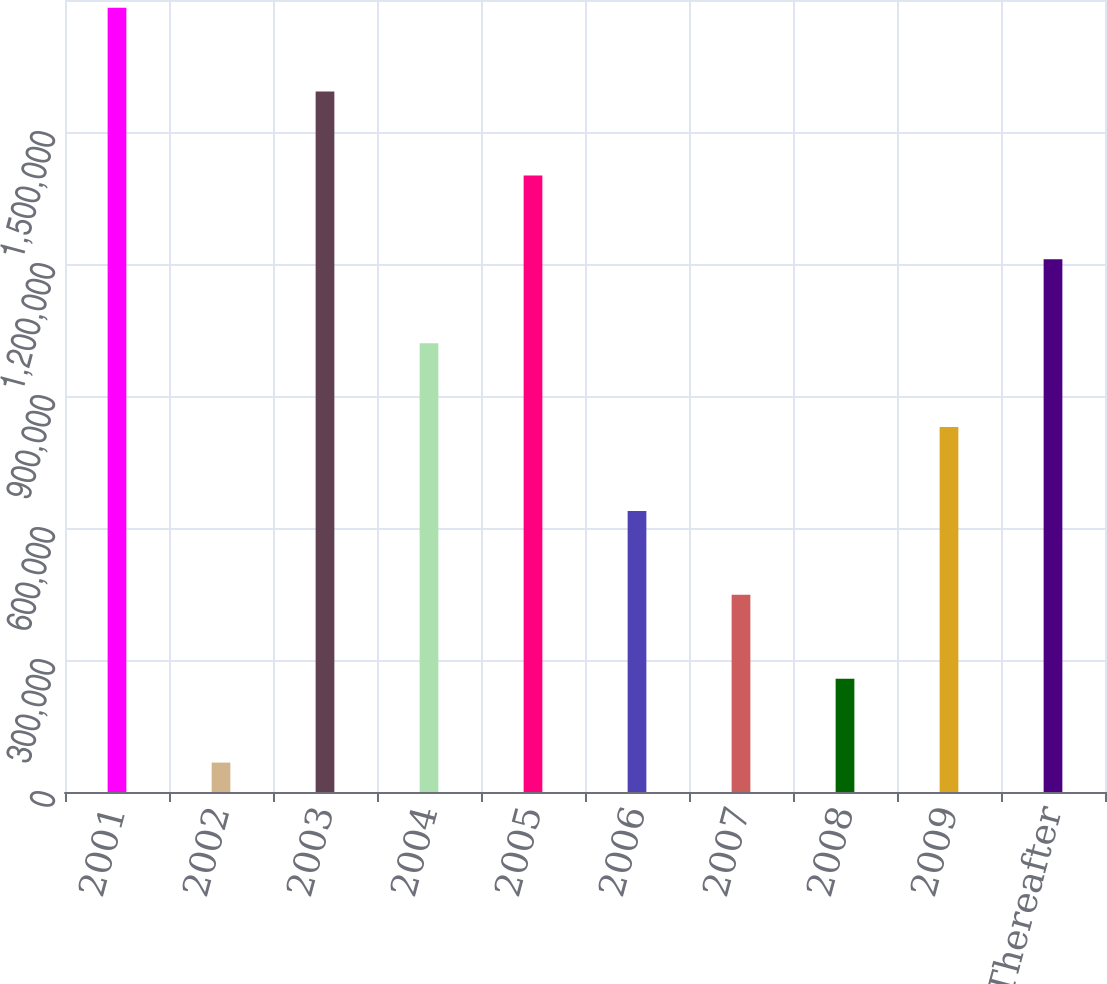Convert chart. <chart><loc_0><loc_0><loc_500><loc_500><bar_chart><fcel>2001<fcel>2002<fcel>2003<fcel>2004<fcel>2005<fcel>2006<fcel>2007<fcel>2008<fcel>2009<fcel>Thereafter<nl><fcel>1.78258e+06<fcel>66847<fcel>1.59194e+06<fcel>1.02003e+06<fcel>1.4013e+06<fcel>638757<fcel>448121<fcel>257484<fcel>829394<fcel>1.21067e+06<nl></chart> 